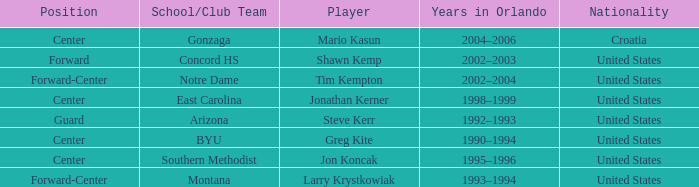What years in orlando have the United States as the nationality, and montana as the school/club team? 1993–1994. 